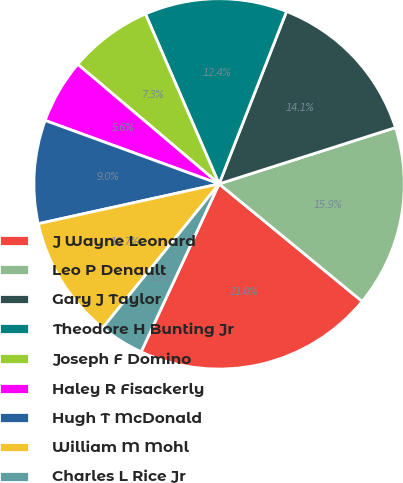Convert chart to OTSL. <chart><loc_0><loc_0><loc_500><loc_500><pie_chart><fcel>J Wayne Leonard<fcel>Leo P Denault<fcel>Gary J Taylor<fcel>Theodore H Bunting Jr<fcel>Joseph F Domino<fcel>Haley R Fisackerly<fcel>Hugh T McDonald<fcel>William M Mohl<fcel>Charles L Rice Jr<nl><fcel>20.98%<fcel>15.86%<fcel>14.15%<fcel>12.44%<fcel>7.32%<fcel>5.61%<fcel>9.02%<fcel>10.73%<fcel>3.9%<nl></chart> 